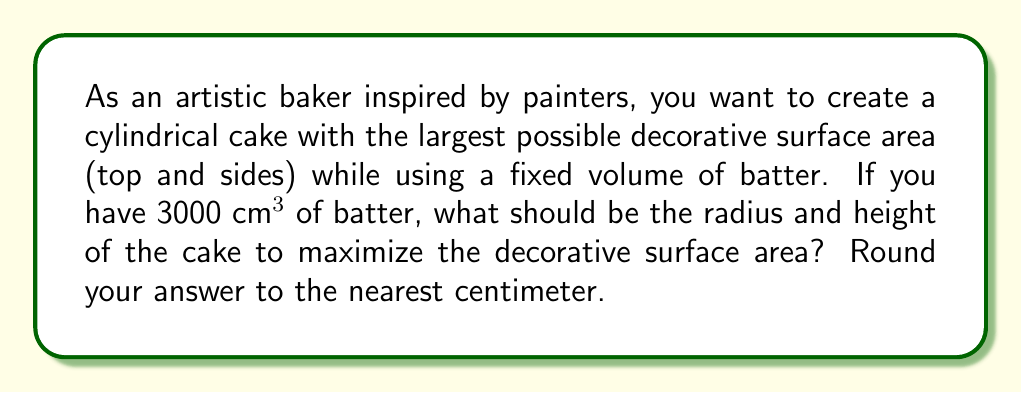Provide a solution to this math problem. Let's approach this step-by-step:

1) Let $r$ be the radius of the cake and $h$ be its height.

2) The volume of a cylinder is given by $V = \pi r^2 h$. We know $V = 3000$ cm³, so:

   $$3000 = \pi r^2 h$$

3) The surface area we want to maximize is the top circle plus the side. This is given by:

   $$A = \pi r^2 + 2\pi r h$$

4) We can express $h$ in terms of $r$ using the volume equation:

   $$h = \frac{3000}{\pi r^2}$$

5) Substituting this into our surface area equation:

   $$A = \pi r^2 + 2\pi r (\frac{3000}{\pi r^2}) = \pi r^2 + \frac{6000}{r}$$

6) To find the maximum, we differentiate $A$ with respect to $r$ and set it to zero:

   $$\frac{dA}{dr} = 2\pi r - \frac{6000}{r^2} = 0$$

7) Solving this equation:

   $$2\pi r^3 = 6000$$
   $$r^3 = \frac{3000}{\pi}$$
   $$r = \sqrt[3]{\frac{3000}{\pi}} \approx 9.1$$

8) We can find $h$ by substituting this value of $r$ back into the equation from step 4:

   $$h = \frac{3000}{\pi (9.1)^2} \approx 11.5$$

9) Rounding to the nearest centimeter:

   $r = 9$ cm and $h = 12$ cm

We can verify that this gives us the maximum surface area by checking values slightly above and below these dimensions.
Answer: The optimal dimensions for the cake are approximately 9 cm for the radius and 12 cm for the height. 